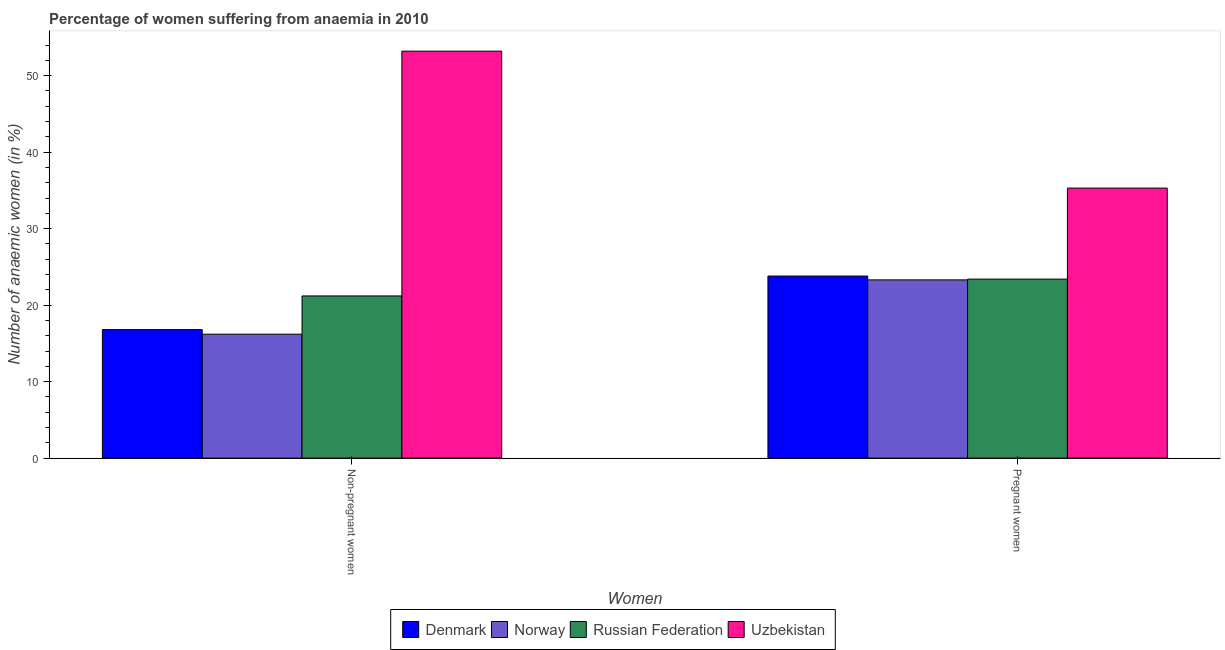How many different coloured bars are there?
Keep it short and to the point. 4. How many groups of bars are there?
Make the answer very short. 2. How many bars are there on the 2nd tick from the left?
Your answer should be very brief. 4. How many bars are there on the 1st tick from the right?
Give a very brief answer. 4. What is the label of the 2nd group of bars from the left?
Your answer should be compact. Pregnant women. What is the percentage of pregnant anaemic women in Russian Federation?
Provide a short and direct response. 23.4. Across all countries, what is the maximum percentage of pregnant anaemic women?
Provide a short and direct response. 35.3. In which country was the percentage of non-pregnant anaemic women maximum?
Your answer should be compact. Uzbekistan. In which country was the percentage of pregnant anaemic women minimum?
Offer a terse response. Norway. What is the total percentage of non-pregnant anaemic women in the graph?
Ensure brevity in your answer.  107.4. What is the difference between the percentage of non-pregnant anaemic women in Norway and that in Russian Federation?
Ensure brevity in your answer.  -5. What is the difference between the percentage of pregnant anaemic women in Russian Federation and the percentage of non-pregnant anaemic women in Denmark?
Offer a very short reply. 6.6. What is the average percentage of pregnant anaemic women per country?
Make the answer very short. 26.45. What is the difference between the percentage of pregnant anaemic women and percentage of non-pregnant anaemic women in Denmark?
Your response must be concise. 7. In how many countries, is the percentage of pregnant anaemic women greater than 50 %?
Provide a short and direct response. 0. What is the ratio of the percentage of pregnant anaemic women in Russian Federation to that in Uzbekistan?
Provide a succinct answer. 0.66. Is the percentage of pregnant anaemic women in Uzbekistan less than that in Norway?
Your response must be concise. No. What does the 3rd bar from the left in Non-pregnant women represents?
Provide a short and direct response. Russian Federation. What does the 2nd bar from the right in Pregnant women represents?
Your response must be concise. Russian Federation. How many countries are there in the graph?
Make the answer very short. 4. What is the difference between two consecutive major ticks on the Y-axis?
Offer a very short reply. 10. Are the values on the major ticks of Y-axis written in scientific E-notation?
Offer a very short reply. No. Does the graph contain any zero values?
Make the answer very short. No. Does the graph contain grids?
Ensure brevity in your answer.  No. Where does the legend appear in the graph?
Provide a succinct answer. Bottom center. What is the title of the graph?
Give a very brief answer. Percentage of women suffering from anaemia in 2010. Does "Vietnam" appear as one of the legend labels in the graph?
Ensure brevity in your answer.  No. What is the label or title of the X-axis?
Your answer should be compact. Women. What is the label or title of the Y-axis?
Provide a succinct answer. Number of anaemic women (in %). What is the Number of anaemic women (in %) of Norway in Non-pregnant women?
Your response must be concise. 16.2. What is the Number of anaemic women (in %) of Russian Federation in Non-pregnant women?
Offer a very short reply. 21.2. What is the Number of anaemic women (in %) in Uzbekistan in Non-pregnant women?
Offer a terse response. 53.2. What is the Number of anaemic women (in %) of Denmark in Pregnant women?
Give a very brief answer. 23.8. What is the Number of anaemic women (in %) of Norway in Pregnant women?
Ensure brevity in your answer.  23.3. What is the Number of anaemic women (in %) of Russian Federation in Pregnant women?
Provide a succinct answer. 23.4. What is the Number of anaemic women (in %) of Uzbekistan in Pregnant women?
Your answer should be very brief. 35.3. Across all Women, what is the maximum Number of anaemic women (in %) in Denmark?
Make the answer very short. 23.8. Across all Women, what is the maximum Number of anaemic women (in %) of Norway?
Offer a terse response. 23.3. Across all Women, what is the maximum Number of anaemic women (in %) of Russian Federation?
Your answer should be compact. 23.4. Across all Women, what is the maximum Number of anaemic women (in %) of Uzbekistan?
Your response must be concise. 53.2. Across all Women, what is the minimum Number of anaemic women (in %) in Denmark?
Keep it short and to the point. 16.8. Across all Women, what is the minimum Number of anaemic women (in %) of Russian Federation?
Provide a short and direct response. 21.2. Across all Women, what is the minimum Number of anaemic women (in %) in Uzbekistan?
Offer a terse response. 35.3. What is the total Number of anaemic women (in %) in Denmark in the graph?
Offer a very short reply. 40.6. What is the total Number of anaemic women (in %) of Norway in the graph?
Give a very brief answer. 39.5. What is the total Number of anaemic women (in %) in Russian Federation in the graph?
Ensure brevity in your answer.  44.6. What is the total Number of anaemic women (in %) in Uzbekistan in the graph?
Ensure brevity in your answer.  88.5. What is the difference between the Number of anaemic women (in %) in Norway in Non-pregnant women and that in Pregnant women?
Keep it short and to the point. -7.1. What is the difference between the Number of anaemic women (in %) of Denmark in Non-pregnant women and the Number of anaemic women (in %) of Norway in Pregnant women?
Give a very brief answer. -6.5. What is the difference between the Number of anaemic women (in %) in Denmark in Non-pregnant women and the Number of anaemic women (in %) in Uzbekistan in Pregnant women?
Provide a short and direct response. -18.5. What is the difference between the Number of anaemic women (in %) in Norway in Non-pregnant women and the Number of anaemic women (in %) in Russian Federation in Pregnant women?
Keep it short and to the point. -7.2. What is the difference between the Number of anaemic women (in %) of Norway in Non-pregnant women and the Number of anaemic women (in %) of Uzbekistan in Pregnant women?
Your response must be concise. -19.1. What is the difference between the Number of anaemic women (in %) in Russian Federation in Non-pregnant women and the Number of anaemic women (in %) in Uzbekistan in Pregnant women?
Your answer should be compact. -14.1. What is the average Number of anaemic women (in %) in Denmark per Women?
Give a very brief answer. 20.3. What is the average Number of anaemic women (in %) of Norway per Women?
Give a very brief answer. 19.75. What is the average Number of anaemic women (in %) of Russian Federation per Women?
Your answer should be compact. 22.3. What is the average Number of anaemic women (in %) of Uzbekistan per Women?
Provide a succinct answer. 44.25. What is the difference between the Number of anaemic women (in %) in Denmark and Number of anaemic women (in %) in Russian Federation in Non-pregnant women?
Ensure brevity in your answer.  -4.4. What is the difference between the Number of anaemic women (in %) in Denmark and Number of anaemic women (in %) in Uzbekistan in Non-pregnant women?
Provide a short and direct response. -36.4. What is the difference between the Number of anaemic women (in %) of Norway and Number of anaemic women (in %) of Russian Federation in Non-pregnant women?
Your response must be concise. -5. What is the difference between the Number of anaemic women (in %) of Norway and Number of anaemic women (in %) of Uzbekistan in Non-pregnant women?
Your answer should be compact. -37. What is the difference between the Number of anaemic women (in %) in Russian Federation and Number of anaemic women (in %) in Uzbekistan in Non-pregnant women?
Offer a terse response. -32. What is the difference between the Number of anaemic women (in %) in Norway and Number of anaemic women (in %) in Russian Federation in Pregnant women?
Ensure brevity in your answer.  -0.1. What is the ratio of the Number of anaemic women (in %) of Denmark in Non-pregnant women to that in Pregnant women?
Your answer should be very brief. 0.71. What is the ratio of the Number of anaemic women (in %) of Norway in Non-pregnant women to that in Pregnant women?
Your answer should be very brief. 0.7. What is the ratio of the Number of anaemic women (in %) of Russian Federation in Non-pregnant women to that in Pregnant women?
Offer a terse response. 0.91. What is the ratio of the Number of anaemic women (in %) in Uzbekistan in Non-pregnant women to that in Pregnant women?
Offer a very short reply. 1.51. What is the difference between the highest and the second highest Number of anaemic women (in %) of Denmark?
Your response must be concise. 7. What is the difference between the highest and the second highest Number of anaemic women (in %) of Norway?
Your answer should be compact. 7.1. What is the difference between the highest and the lowest Number of anaemic women (in %) of Denmark?
Your response must be concise. 7. What is the difference between the highest and the lowest Number of anaemic women (in %) in Russian Federation?
Your response must be concise. 2.2. 